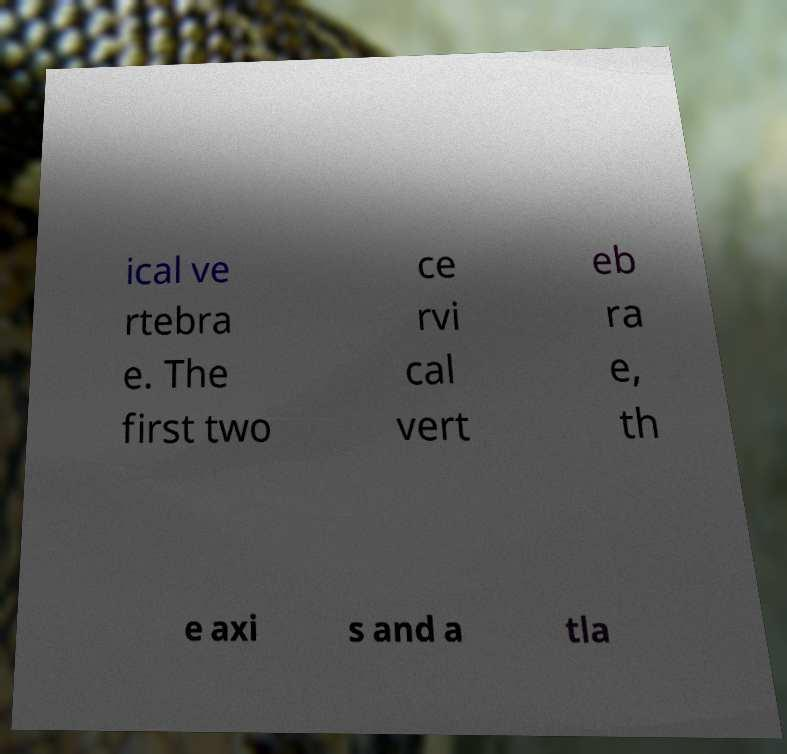Please read and relay the text visible in this image. What does it say? ical ve rtebra e. The first two ce rvi cal vert eb ra e, th e axi s and a tla 